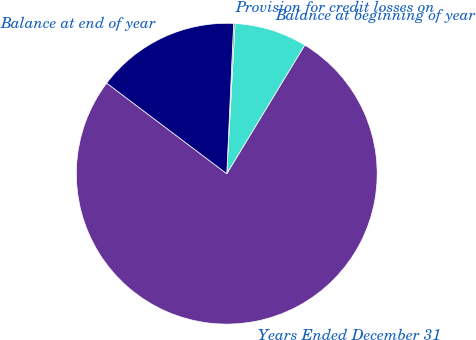Convert chart to OTSL. <chart><loc_0><loc_0><loc_500><loc_500><pie_chart><fcel>Years Ended December 31<fcel>Balance at beginning of year<fcel>Provision for credit losses on<fcel>Balance at end of year<nl><fcel>76.61%<fcel>7.8%<fcel>0.15%<fcel>15.44%<nl></chart> 